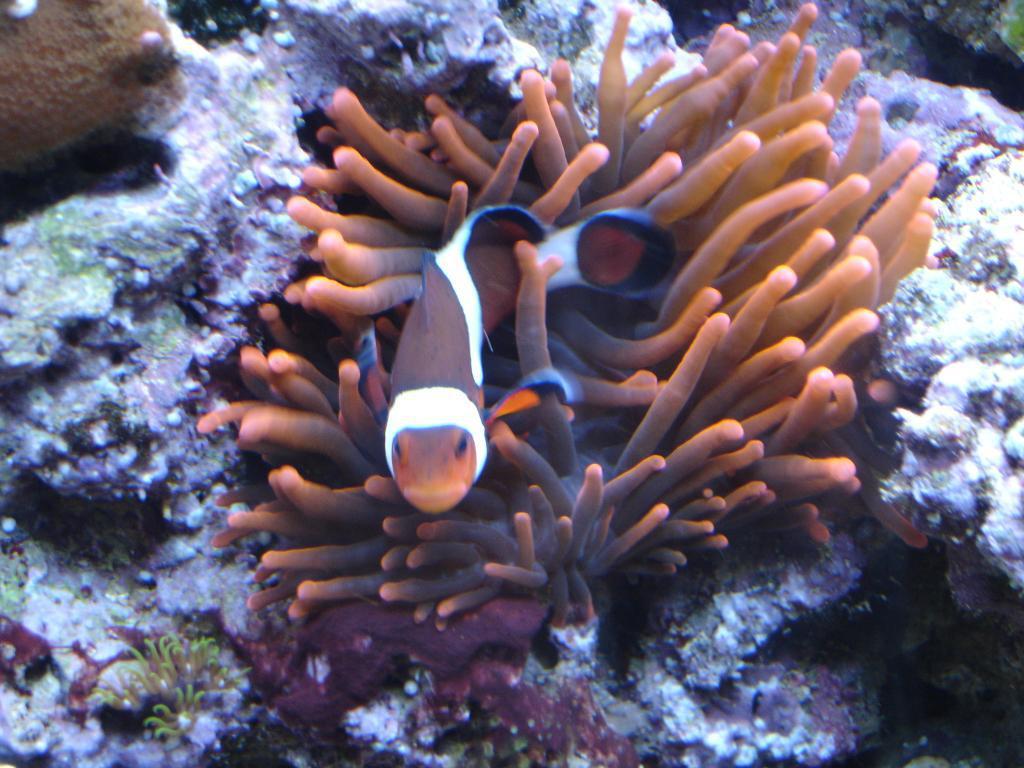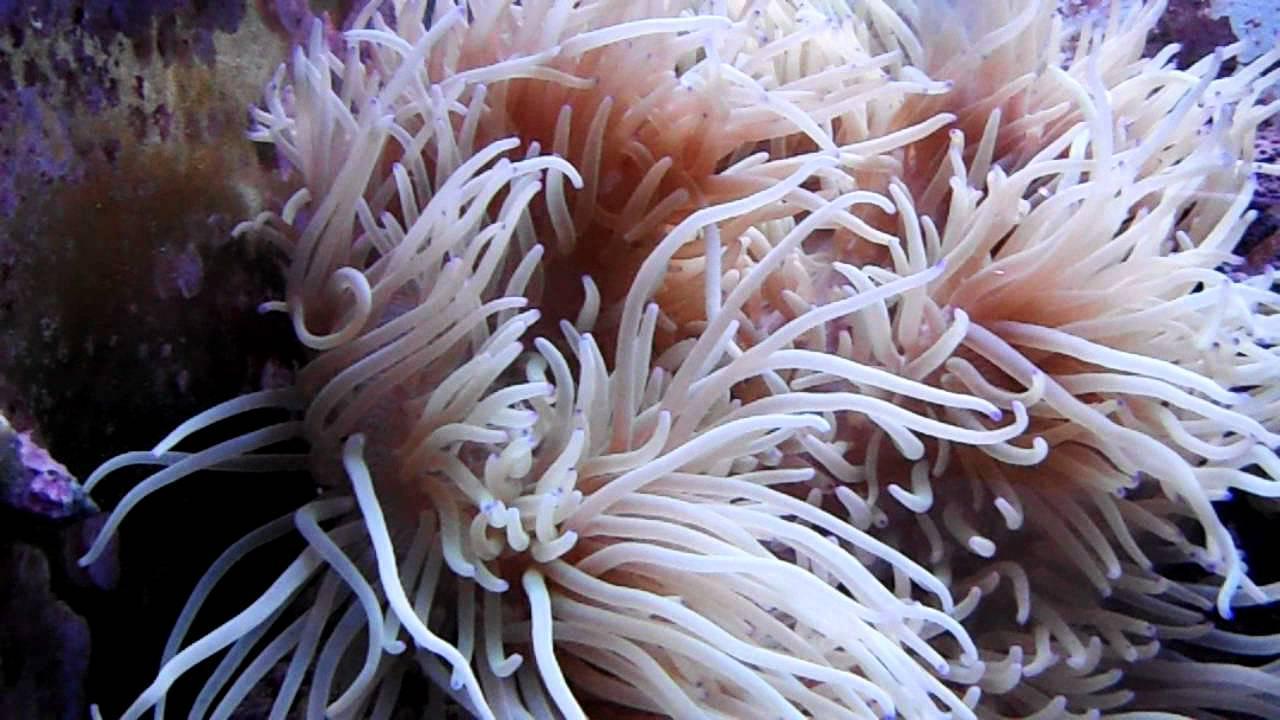The first image is the image on the left, the second image is the image on the right. Assess this claim about the two images: "At least one clown fish is nestled among the sea anemones.". Correct or not? Answer yes or no. Yes. The first image is the image on the left, the second image is the image on the right. For the images displayed, is the sentence "One image shows the reddish-orange tinged front claws of a crustacean emerging from something with green tendrils." factually correct? Answer yes or no. No. 